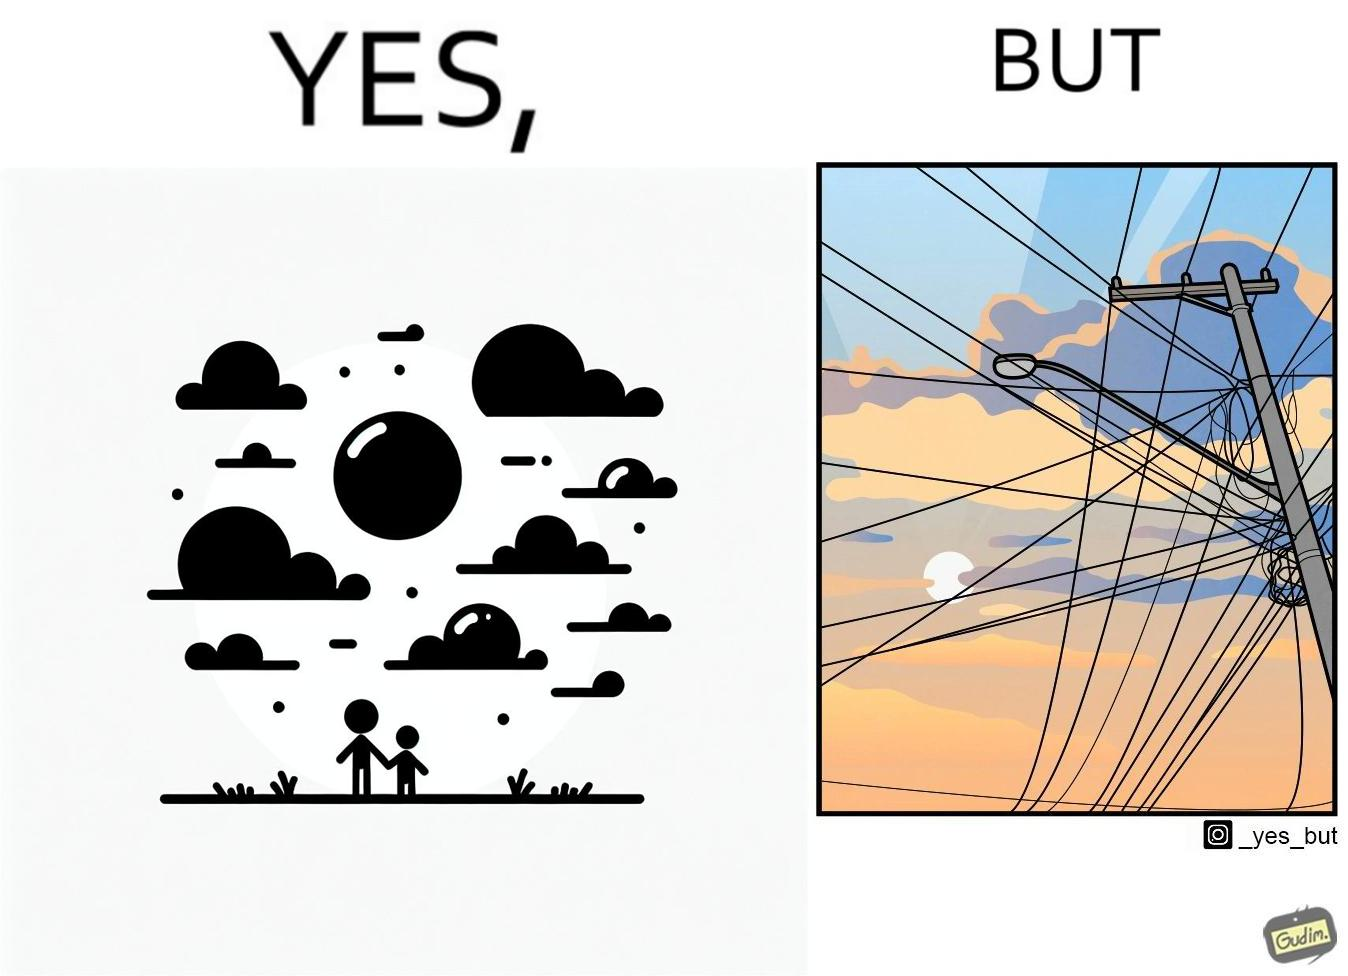Explain why this image is satirical. The image is ironic, because in the first image clear sky is visible but in the second image the same view is getting blocked due to the electricity pole 